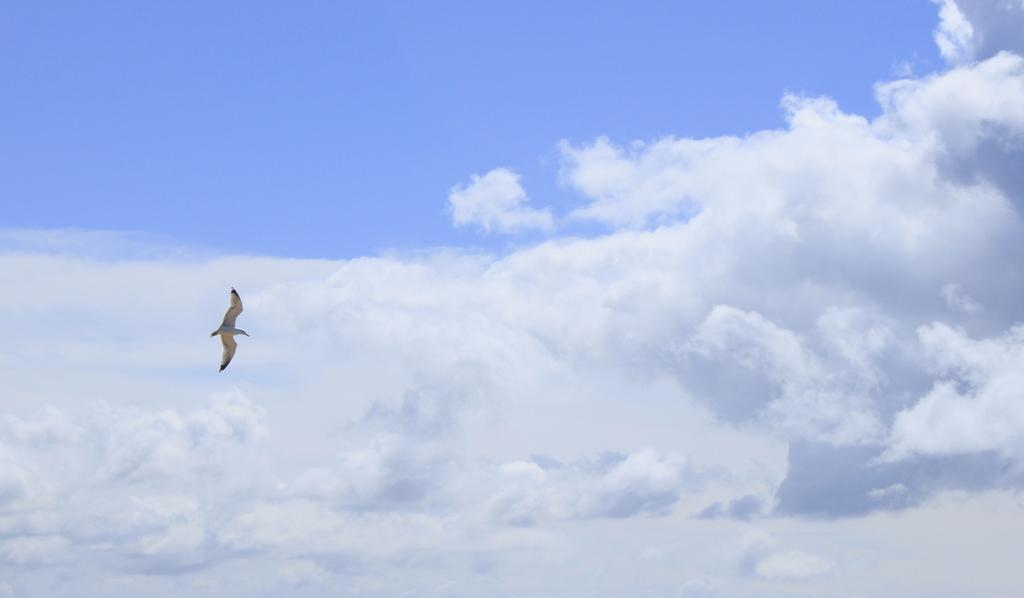What type of animal can be seen in the image? There is a bird in the image. What is the bird doing in the image? The bird is flying in the image. Where is the bird located in the image? The bird is in the sky in the image. What can be seen in the background of the image? There are clouds in the background of the image. What is the color of the sky in the image? The sky is blue in color in the image. What type of advice can be seen written on the lamp in the image? There is no lamp present in the image, so no advice can be seen written on it. 